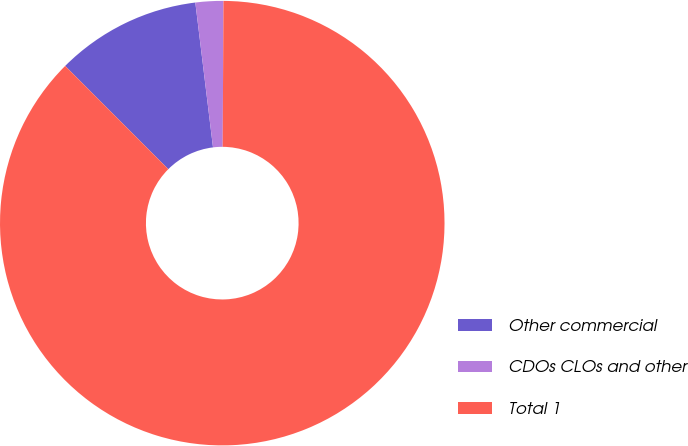Convert chart to OTSL. <chart><loc_0><loc_0><loc_500><loc_500><pie_chart><fcel>Other commercial<fcel>CDOs CLOs and other<fcel>Total 1<nl><fcel>10.56%<fcel>2.02%<fcel>87.42%<nl></chart> 